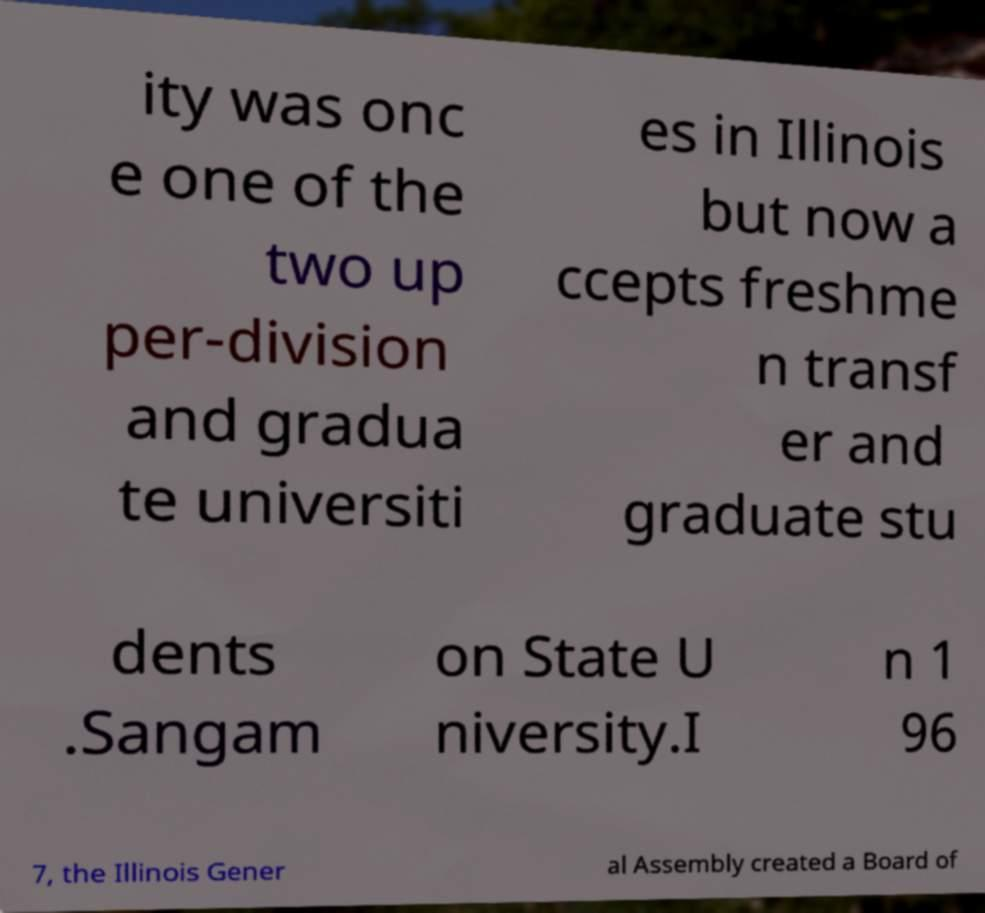For documentation purposes, I need the text within this image transcribed. Could you provide that? ity was onc e one of the two up per-division and gradua te universiti es in Illinois but now a ccepts freshme n transf er and graduate stu dents .Sangam on State U niversity.I n 1 96 7, the Illinois Gener al Assembly created a Board of 